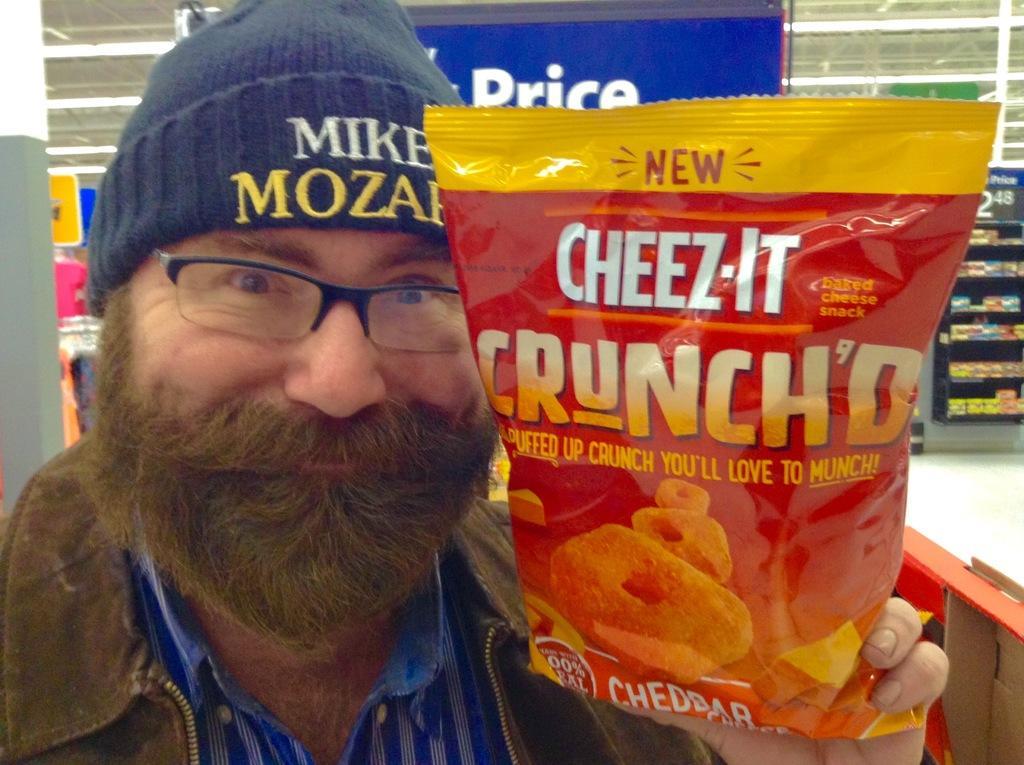How would you summarize this image in a sentence or two? In this picture we can see a person holding a packet, he is wearing a cap, spectacles and in the background we can see a floor, pillar, poster, shelves, lights and some objects. 